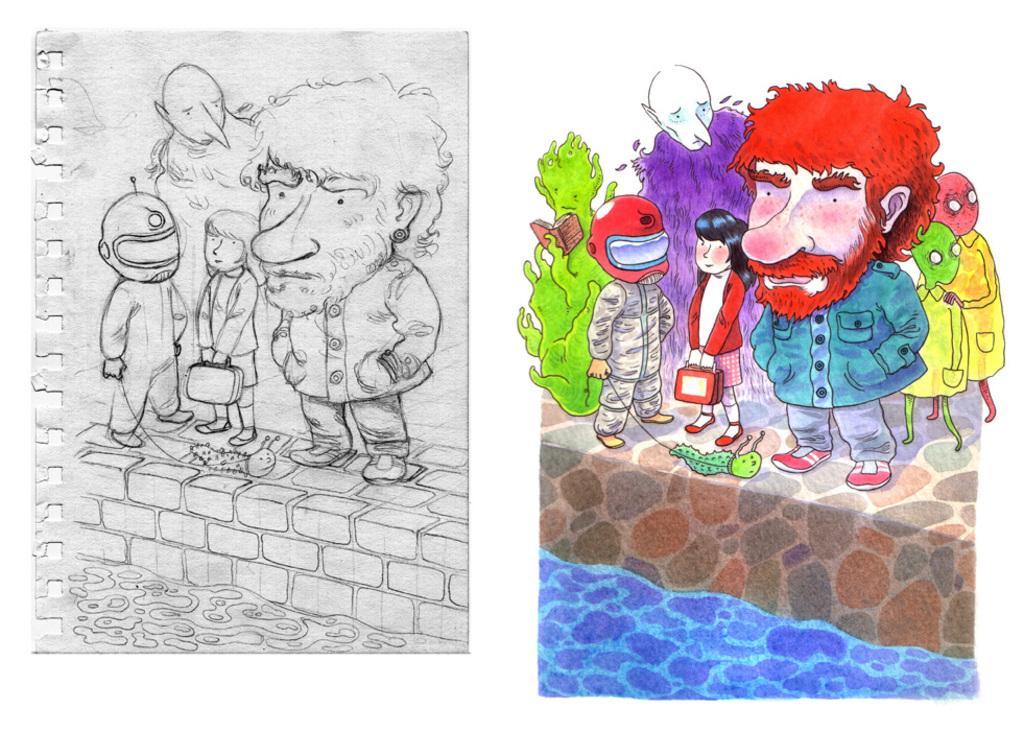Describe this image in one or two sentences. This picture shows a painting and a drawing on the paper. We see cartoons. 